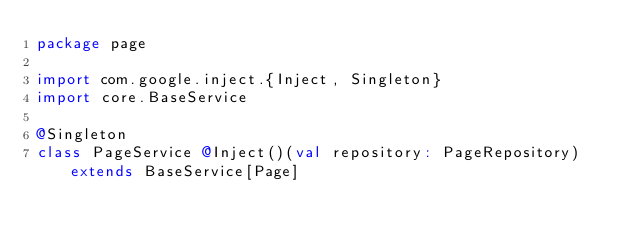Convert code to text. <code><loc_0><loc_0><loc_500><loc_500><_Scala_>package page

import com.google.inject.{Inject, Singleton}
import core.BaseService

@Singleton
class PageService @Inject()(val repository: PageRepository) extends BaseService[Page]
</code> 